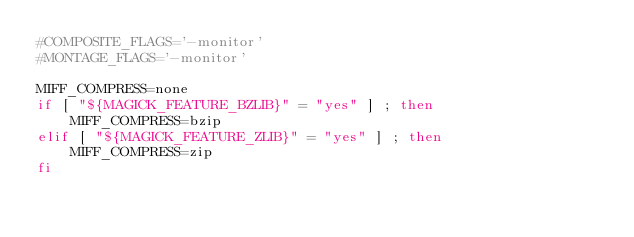<code> <loc_0><loc_0><loc_500><loc_500><_Bash_>#COMPOSITE_FLAGS='-monitor'
#MONTAGE_FLAGS='-monitor'

MIFF_COMPRESS=none
if [ "${MAGICK_FEATURE_BZLIB}" = "yes" ] ; then
    MIFF_COMPRESS=bzip
elif [ "${MAGICK_FEATURE_ZLIB}" = "yes" ] ; then
    MIFF_COMPRESS=zip
fi
</code> 